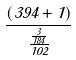Convert formula to latex. <formula><loc_0><loc_0><loc_500><loc_500>\frac { ( 3 9 4 + 1 ) } { \frac { \frac { 3 } { 1 8 4 } } { 1 0 2 } }</formula> 